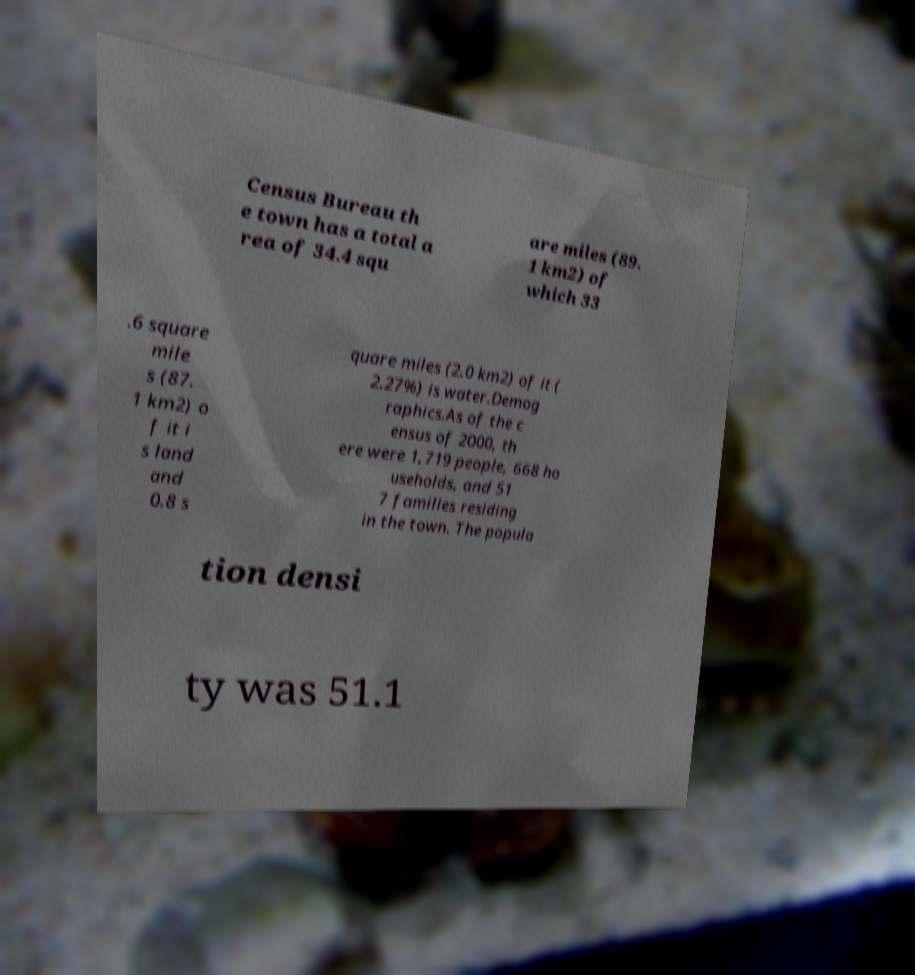For documentation purposes, I need the text within this image transcribed. Could you provide that? Census Bureau th e town has a total a rea of 34.4 squ are miles (89. 1 km2) of which 33 .6 square mile s (87. 1 km2) o f it i s land and 0.8 s quare miles (2.0 km2) of it ( 2.27%) is water.Demog raphics.As of the c ensus of 2000, th ere were 1,719 people, 668 ho useholds, and 51 7 families residing in the town. The popula tion densi ty was 51.1 